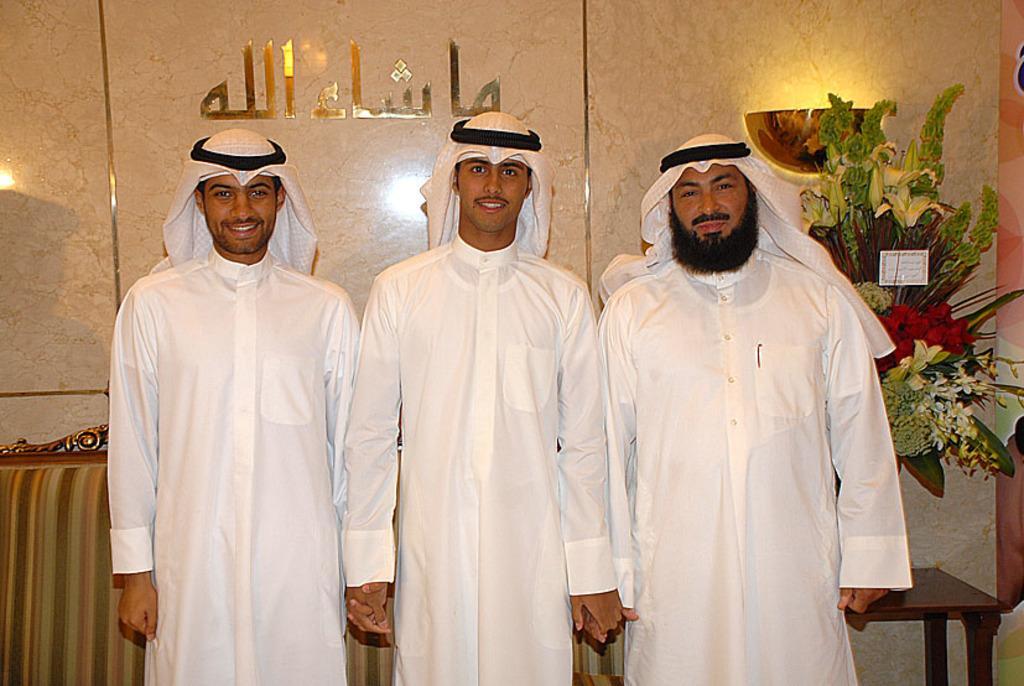Can you describe this image briefly? In this image I see 3 men who are wearing the same dress and 3 of them are smiling, In the background I see a sofa, a table on which there are flowers and the wall. 